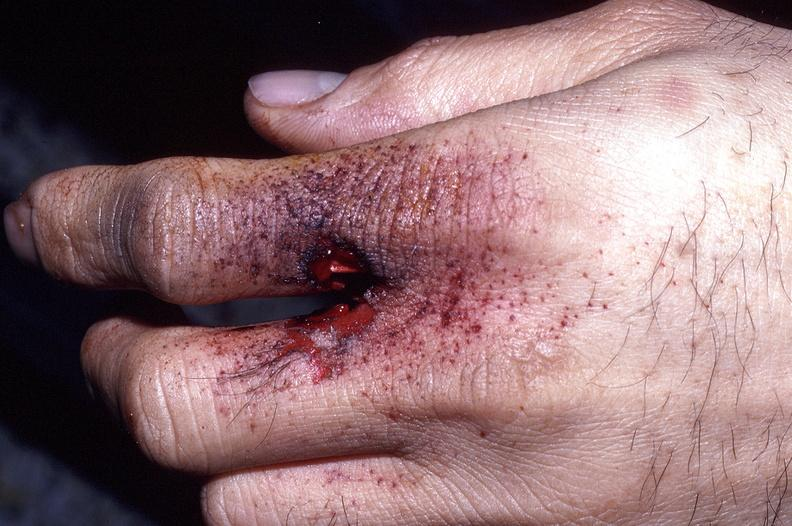does mesothelioma show hand, gunshot entrance wound, intermediate range, powder burns freckling?
Answer the question using a single word or phrase. No 